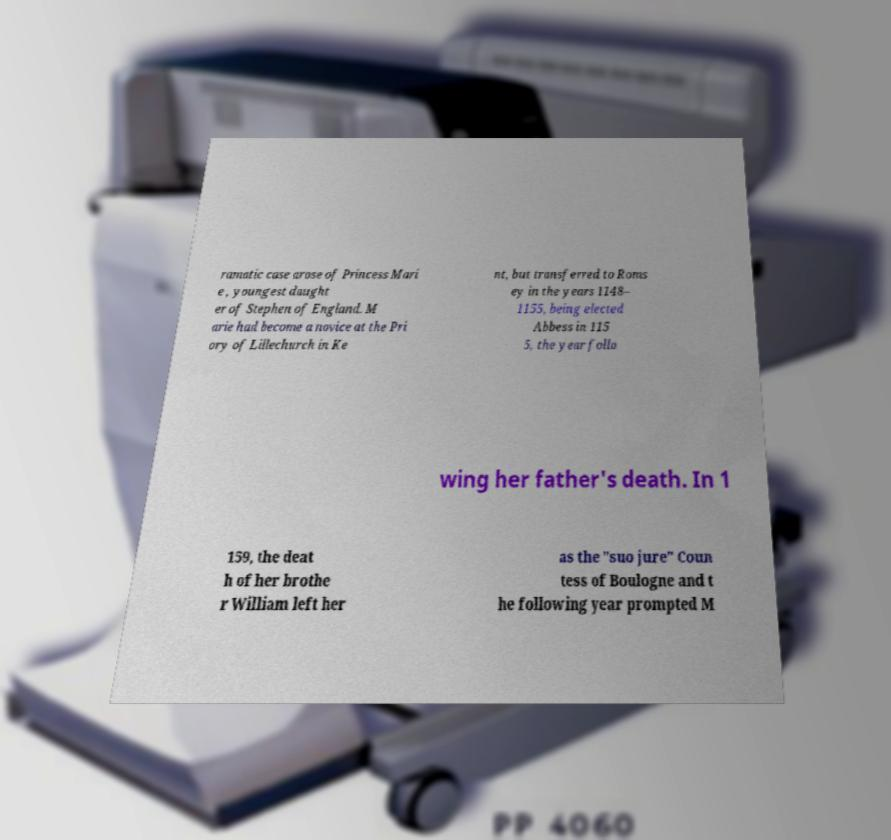Can you accurately transcribe the text from the provided image for me? ramatic case arose of Princess Mari e , youngest daught er of Stephen of England. M arie had become a novice at the Pri ory of Lillechurch in Ke nt, but transferred to Roms ey in the years 1148– 1155, being elected Abbess in 115 5, the year follo wing her father's death. In 1 159, the deat h of her brothe r William left her as the "suo jure" Coun tess of Boulogne and t he following year prompted M 